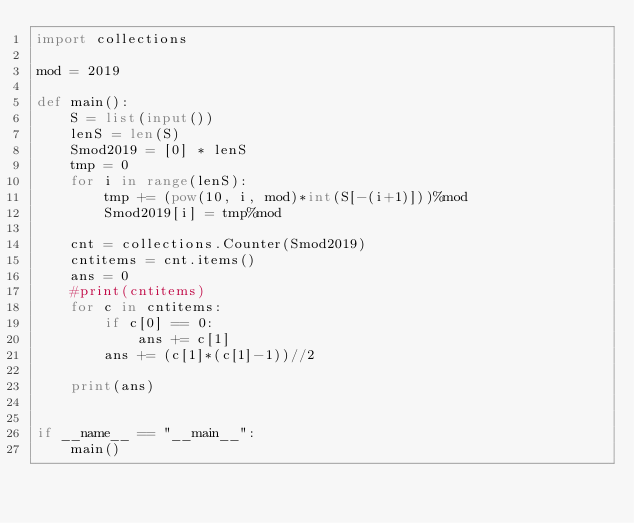Convert code to text. <code><loc_0><loc_0><loc_500><loc_500><_Python_>import collections

mod = 2019

def main():
    S = list(input())
    lenS = len(S)
    Smod2019 = [0] * lenS
    tmp = 0
    for i in range(lenS):
        tmp += (pow(10, i, mod)*int(S[-(i+1)]))%mod
        Smod2019[i] = tmp%mod
    
    cnt = collections.Counter(Smod2019)
    cntitems = cnt.items()
    ans = 0
    #print(cntitems)
    for c in cntitems:
        if c[0] == 0:
            ans += c[1]
        ans += (c[1]*(c[1]-1))//2
    
    print(ans)


if __name__ == "__main__":
    main()
</code> 